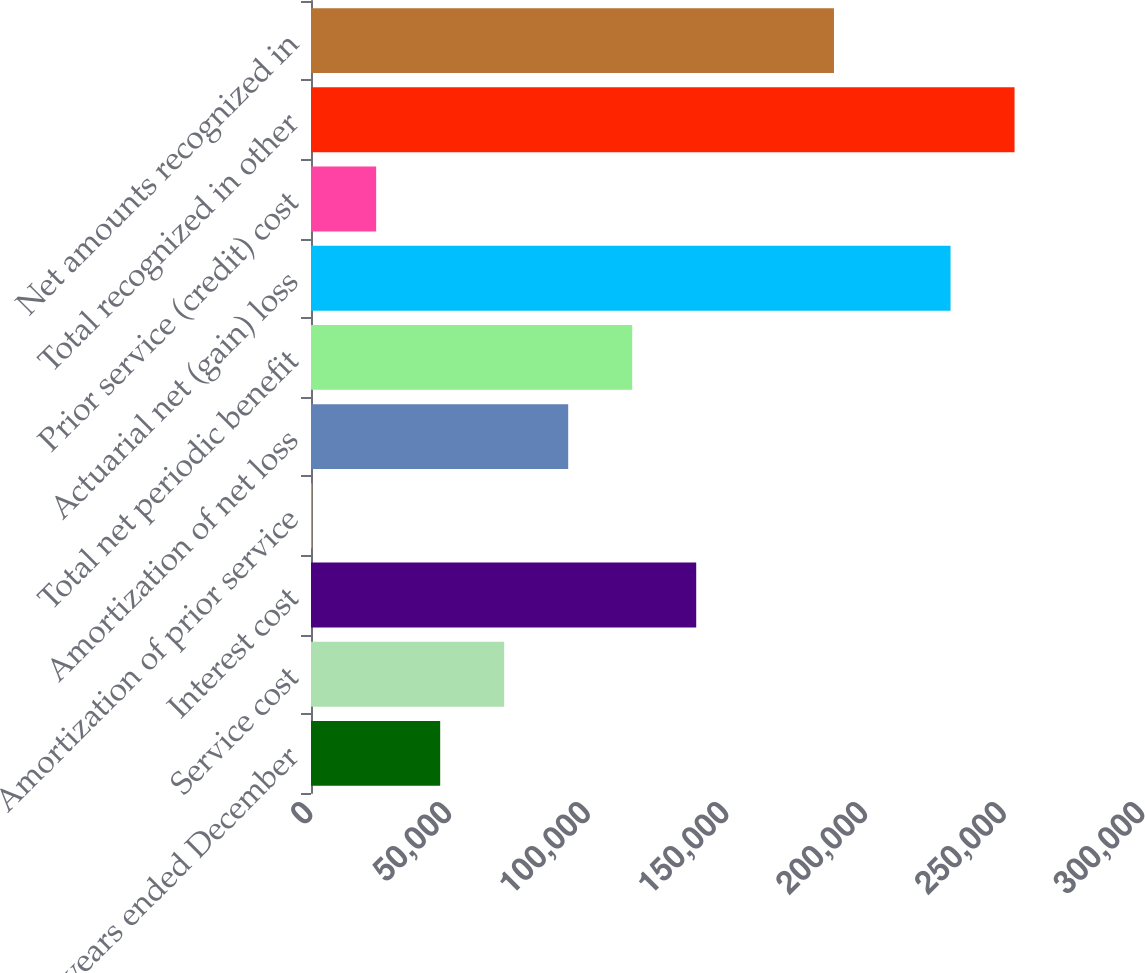<chart> <loc_0><loc_0><loc_500><loc_500><bar_chart><fcel>For the years ended December<fcel>Service cost<fcel>Interest cost<fcel>Amortization of prior service<fcel>Amortization of net loss<fcel>Total net periodic benefit<fcel>Actuarial net (gain) loss<fcel>Prior service (credit) cost<fcel>Total recognized in other<fcel>Net amounts recognized in<nl><fcel>46581.2<fcel>69660.8<fcel>138900<fcel>422<fcel>92740.4<fcel>115820<fcel>230605<fcel>23501.6<fcel>253685<fcel>188572<nl></chart> 